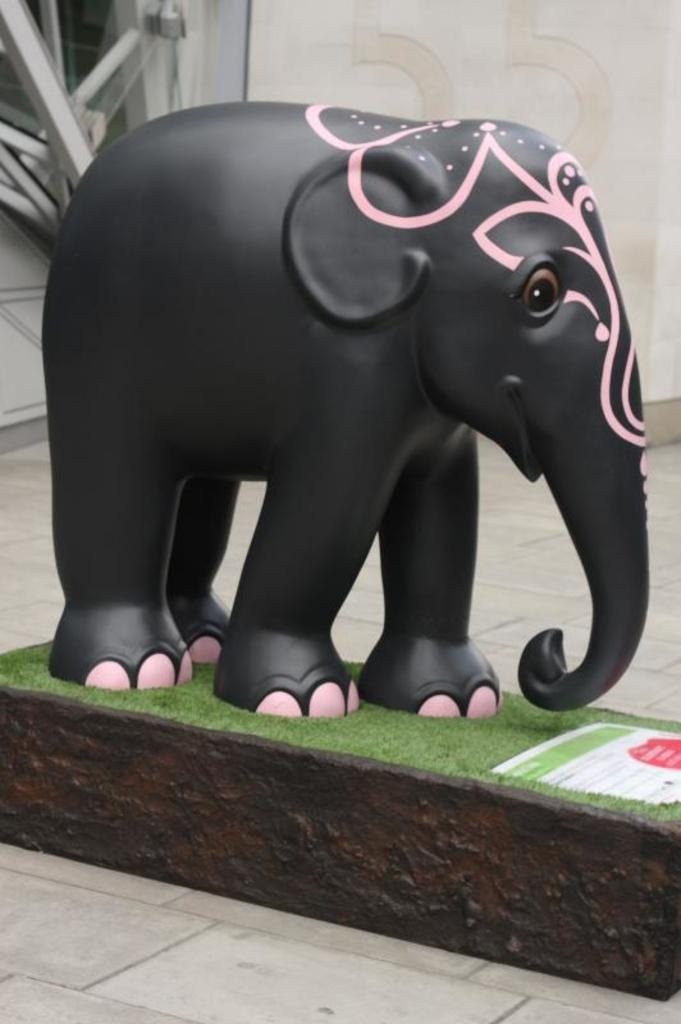What is the main subject of the image? There is a statue of an elephant in the image. What else can be seen in the image besides the elephant statue? There is an information board in the image. What is visible in the background of the image? There is a wall in the background of the image. How does the statue of the elephant stretch in the image? The statue of the elephant does not stretch in the image, as it is a stationary object made of a non-flexible material. 